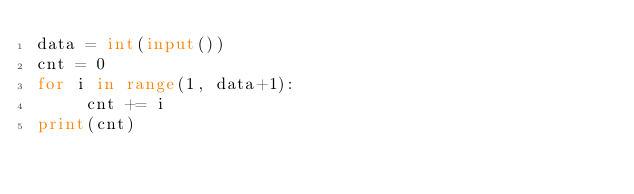Convert code to text. <code><loc_0><loc_0><loc_500><loc_500><_Python_>data = int(input())
cnt = 0
for i in range(1, data+1):
     cnt += i
print(cnt)</code> 